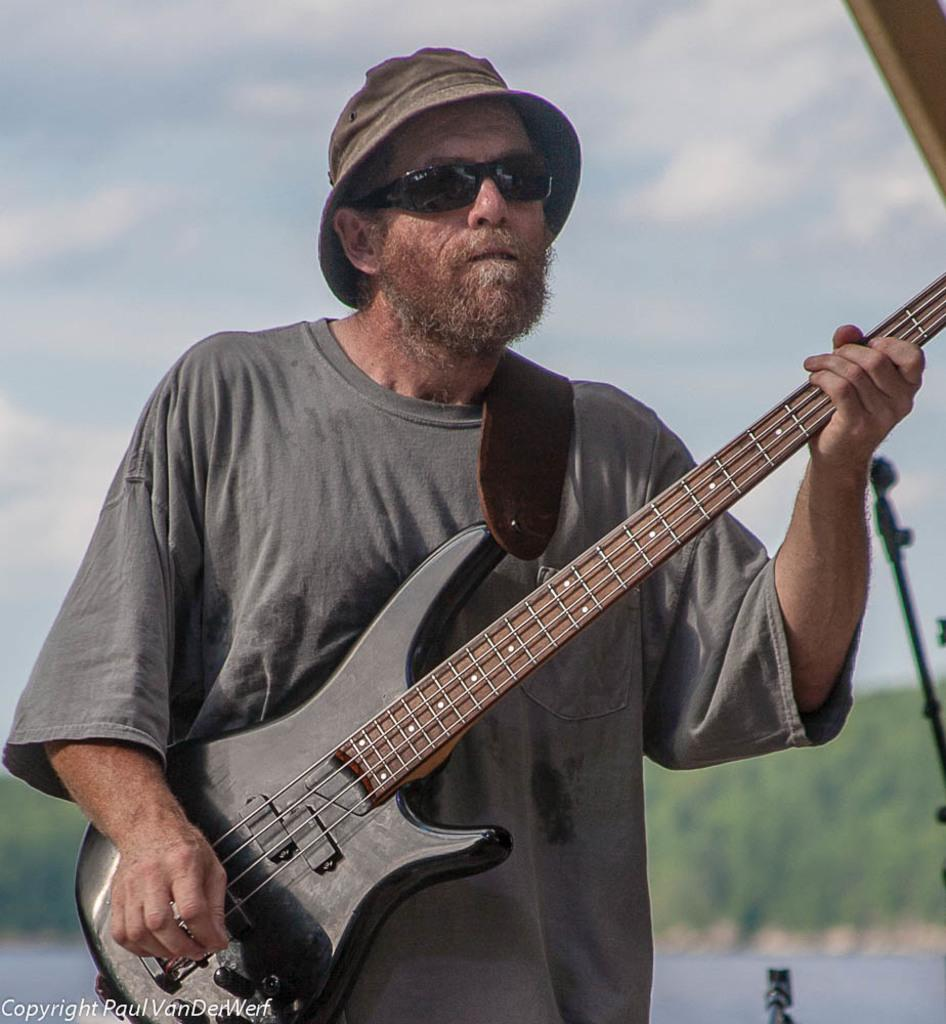What is the main subject of the image? There is a man in the image. What is the man doing in the image? The man is standing and playing a guitar. What can be seen in the background of the image? The sky and trees are visible in the image. How would you describe the sky in the image? The sky appears to be cloudy. What type of bag is the man carrying on his back in the image? There is no bag visible on the man's back in the image. How does the man turn around while playing the guitar in the image? The man is not turning around in the image; he is standing and playing the guitar facing forward. 